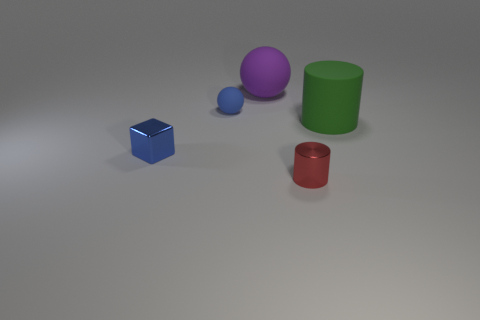Is there any other thing that has the same shape as the small blue metallic thing?
Offer a very short reply. No. There is a tiny block that is the same color as the tiny rubber sphere; what is its material?
Your answer should be compact. Metal. Is the size of the red cylinder the same as the purple object?
Your answer should be compact. No. Is the color of the small matte thing the same as the tiny metal cube?
Keep it short and to the point. Yes. There is a blue thing that is right of the tiny blue thing that is in front of the green rubber object; what is its material?
Keep it short and to the point. Rubber. There is a red object that is the same shape as the large green thing; what is its material?
Provide a short and direct response. Metal. Is the size of the blue thing behind the green matte thing the same as the tiny blue shiny block?
Provide a succinct answer. Yes. What number of matte things are green cylinders or purple objects?
Give a very brief answer. 2. There is a thing that is right of the tiny blue cube and in front of the matte cylinder; what is its material?
Keep it short and to the point. Metal. Do the big purple sphere and the red object have the same material?
Your response must be concise. No. 